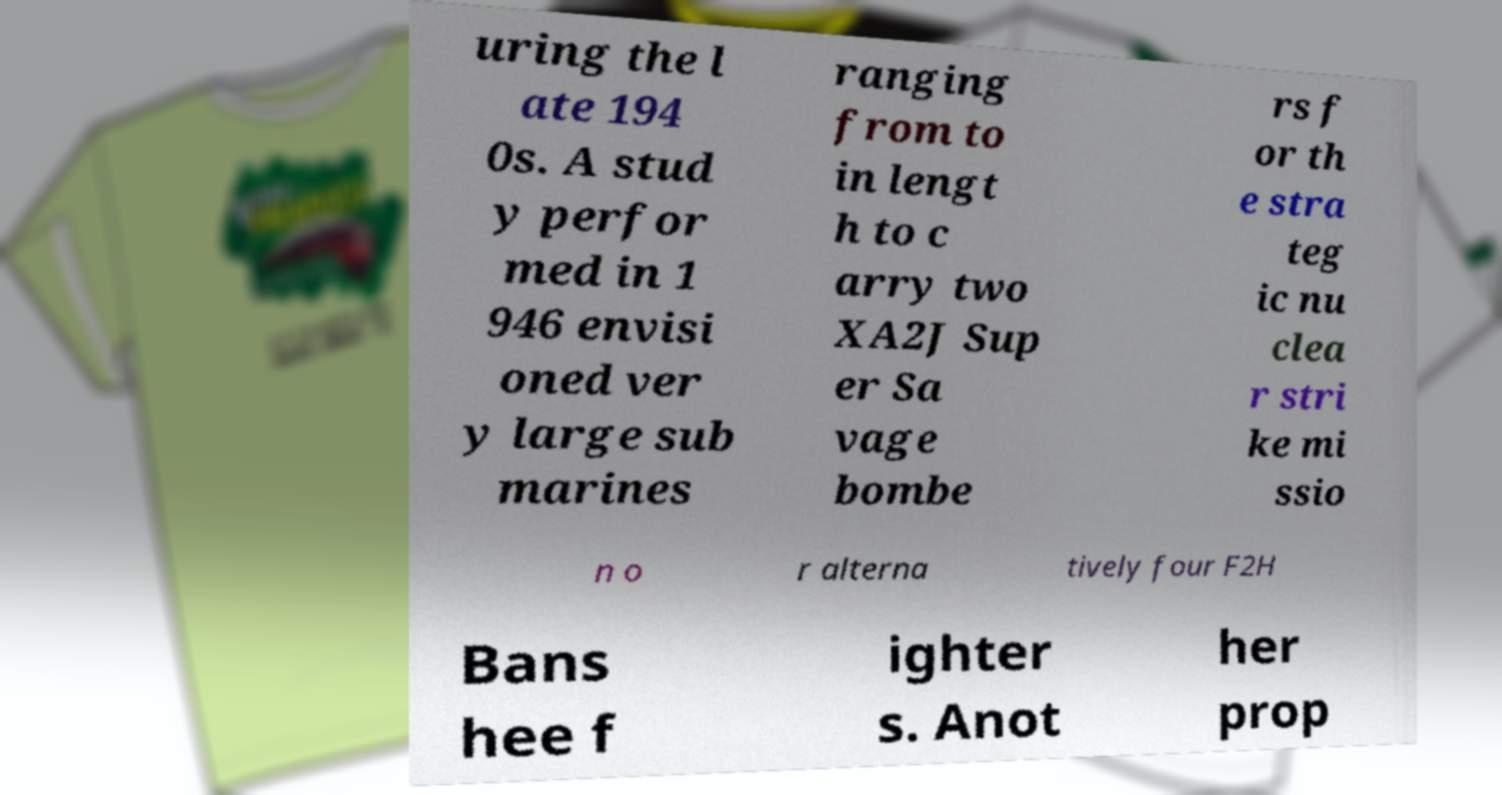Please identify and transcribe the text found in this image. uring the l ate 194 0s. A stud y perfor med in 1 946 envisi oned ver y large sub marines ranging from to in lengt h to c arry two XA2J Sup er Sa vage bombe rs f or th e stra teg ic nu clea r stri ke mi ssio n o r alterna tively four F2H Bans hee f ighter s. Anot her prop 